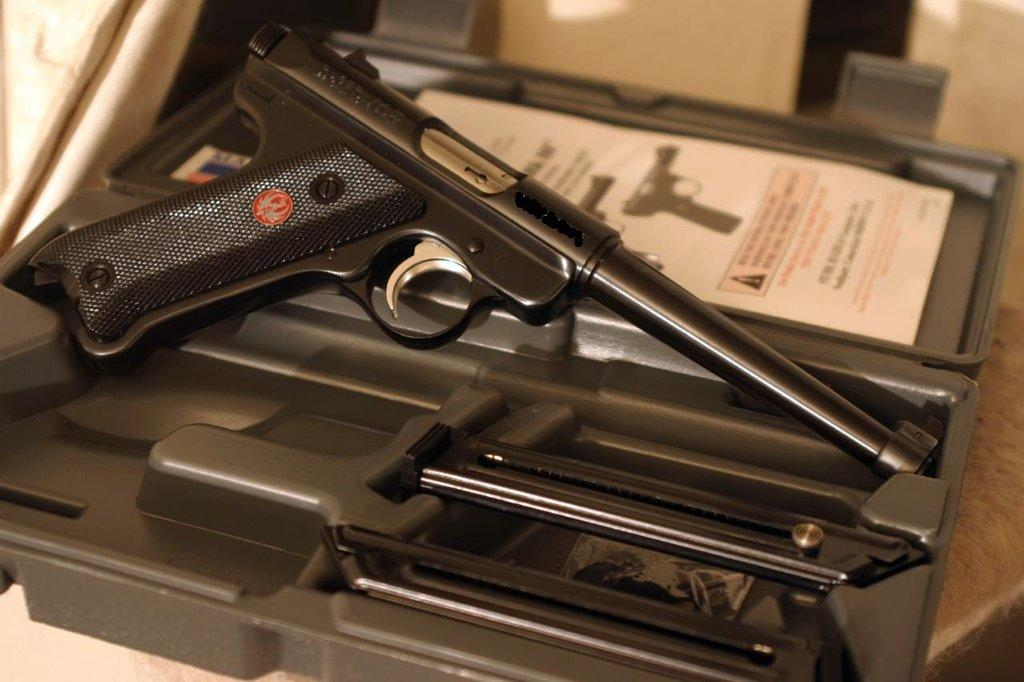What is the main object in the image? There is a gun in the image. Where is the gun placed? The gun is kept on a gun box. What type of organization is responsible for the insects in the image? There are no insects present in the image, so it is not possible to determine which organization might be responsible for them. 